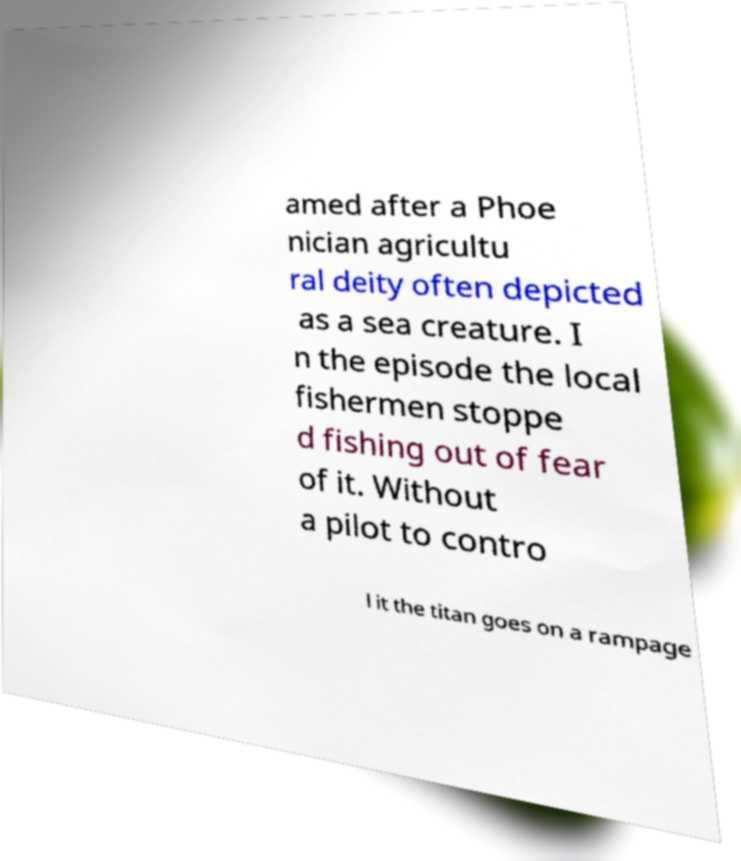Please read and relay the text visible in this image. What does it say? amed after a Phoe nician agricultu ral deity often depicted as a sea creature. I n the episode the local fishermen stoppe d fishing out of fear of it. Without a pilot to contro l it the titan goes on a rampage 